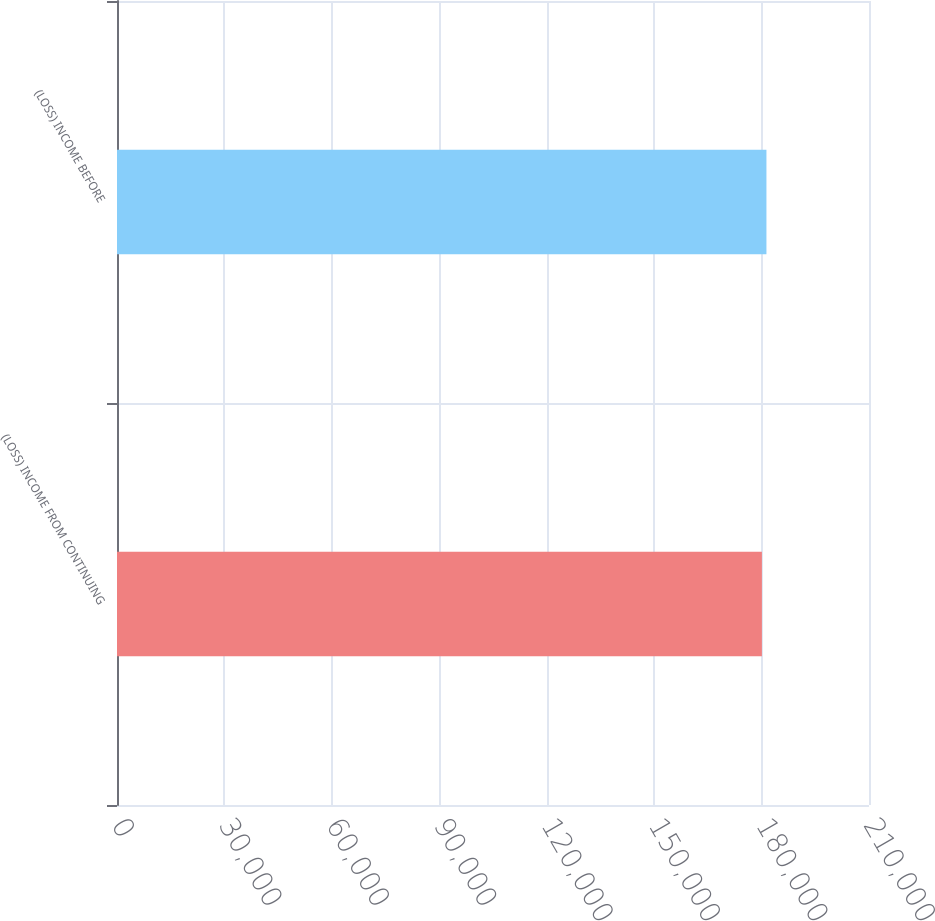<chart> <loc_0><loc_0><loc_500><loc_500><bar_chart><fcel>(LOSS) INCOME FROM CONTINUING<fcel>(LOSS) INCOME BEFORE<nl><fcel>180093<fcel>181359<nl></chart> 